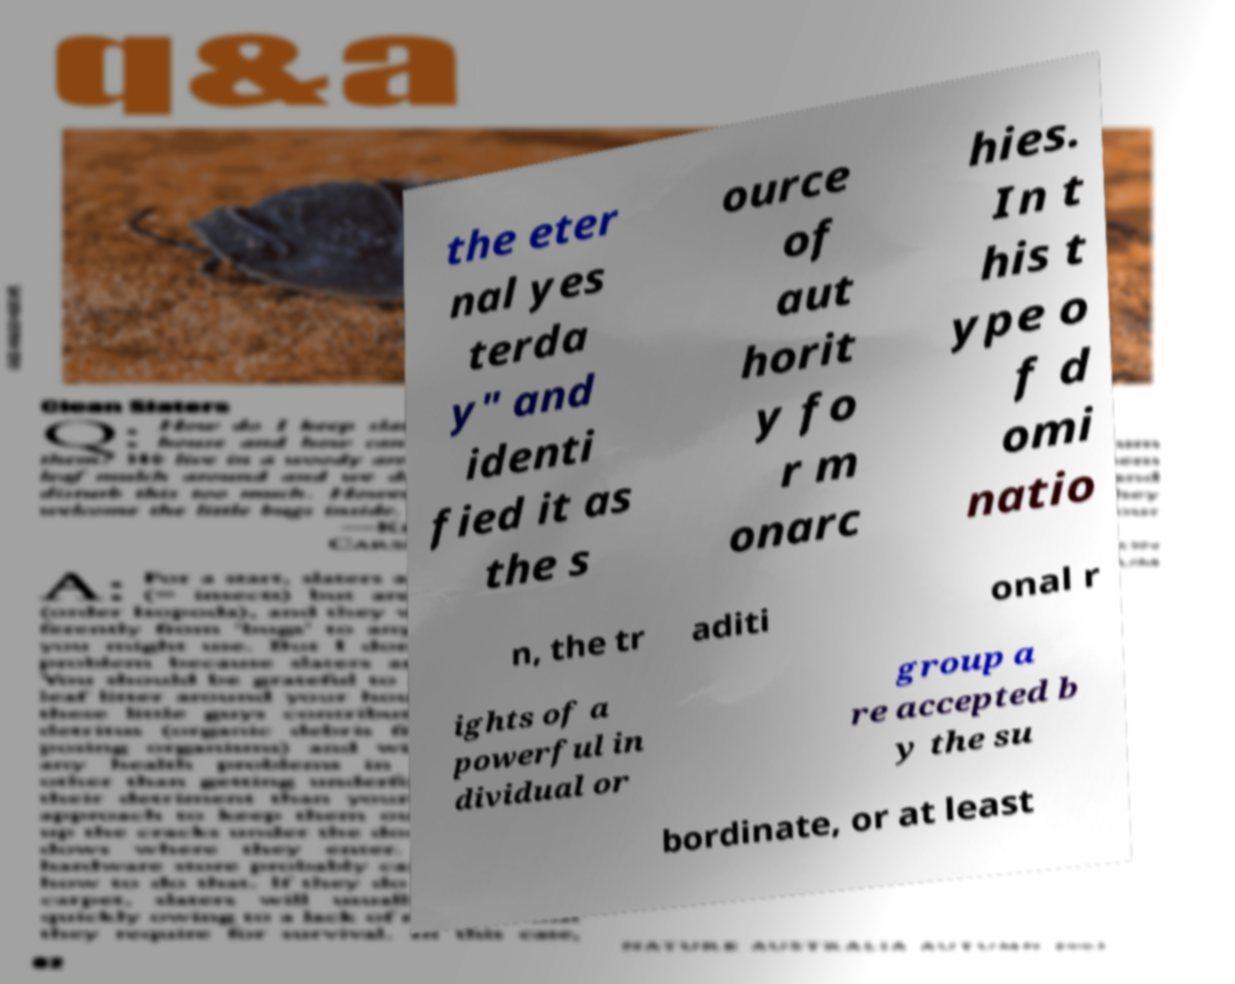Could you assist in decoding the text presented in this image and type it out clearly? the eter nal yes terda y" and identi fied it as the s ource of aut horit y fo r m onarc hies. In t his t ype o f d omi natio n, the tr aditi onal r ights of a powerful in dividual or group a re accepted b y the su bordinate, or at least 